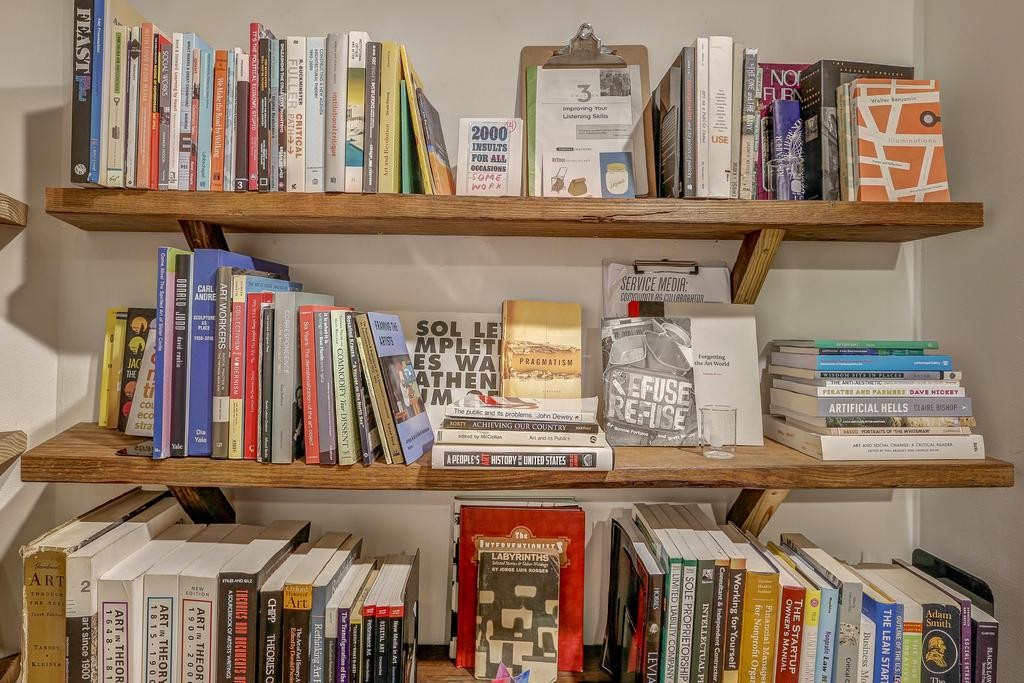<image>
Describe the image concisely. Shelf full of books including one called "Pragmatism". 